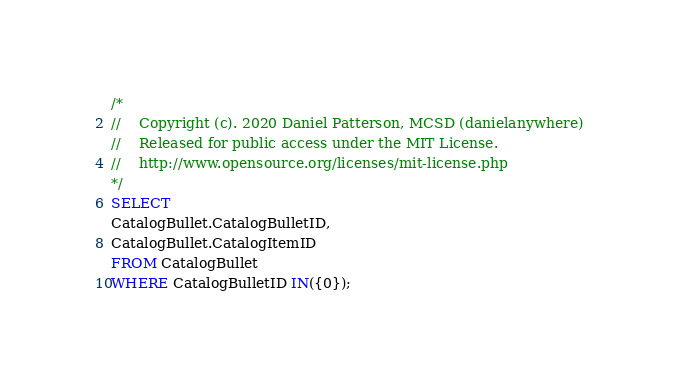Convert code to text. <code><loc_0><loc_0><loc_500><loc_500><_SQL_>/*
//	Copyright (c). 2020 Daniel Patterson, MCSD (danielanywhere)
//	Released for public access under the MIT License.
//	http://www.opensource.org/licenses/mit-license.php
*/
SELECT
CatalogBullet.CatalogBulletID,
CatalogBullet.CatalogItemID
FROM CatalogBullet
WHERE CatalogBulletID IN({0});
</code> 